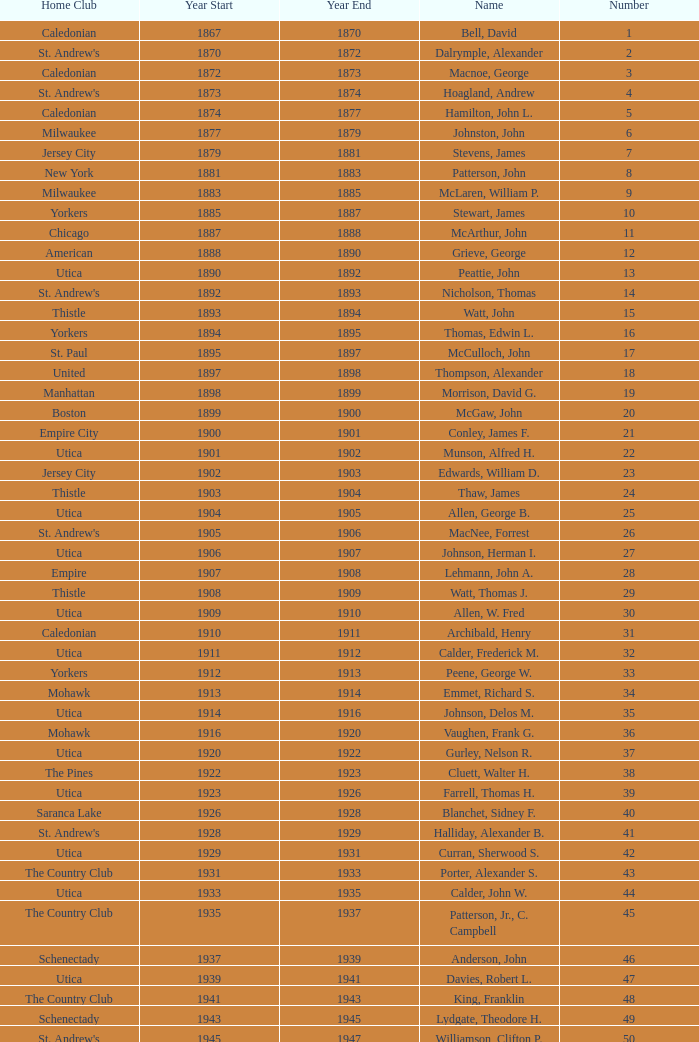Which Number has a Name of cooper, c. kenneth, and a Year End larger than 1984? None. Could you parse the entire table? {'header': ['Home Club', 'Year Start', 'Year End', 'Name', 'Number'], 'rows': [['Caledonian', '1867', '1870', 'Bell, David', '1'], ["St. Andrew's", '1870', '1872', 'Dalrymple, Alexander', '2'], ['Caledonian', '1872', '1873', 'Macnoe, George', '3'], ["St. Andrew's", '1873', '1874', 'Hoagland, Andrew', '4'], ['Caledonian', '1874', '1877', 'Hamilton, John L.', '5'], ['Milwaukee', '1877', '1879', 'Johnston, John', '6'], ['Jersey City', '1879', '1881', 'Stevens, James', '7'], ['New York', '1881', '1883', 'Patterson, John', '8'], ['Milwaukee', '1883', '1885', 'McLaren, William P.', '9'], ['Yorkers', '1885', '1887', 'Stewart, James', '10'], ['Chicago', '1887', '1888', 'McArthur, John', '11'], ['American', '1888', '1890', 'Grieve, George', '12'], ['Utica', '1890', '1892', 'Peattie, John', '13'], ["St. Andrew's", '1892', '1893', 'Nicholson, Thomas', '14'], ['Thistle', '1893', '1894', 'Watt, John', '15'], ['Yorkers', '1894', '1895', 'Thomas, Edwin L.', '16'], ['St. Paul', '1895', '1897', 'McCulloch, John', '17'], ['United', '1897', '1898', 'Thompson, Alexander', '18'], ['Manhattan', '1898', '1899', 'Morrison, David G.', '19'], ['Boston', '1899', '1900', 'McGaw, John', '20'], ['Empire City', '1900', '1901', 'Conley, James F.', '21'], ['Utica', '1901', '1902', 'Munson, Alfred H.', '22'], ['Jersey City', '1902', '1903', 'Edwards, William D.', '23'], ['Thistle', '1903', '1904', 'Thaw, James', '24'], ['Utica', '1904', '1905', 'Allen, George B.', '25'], ["St. Andrew's", '1905', '1906', 'MacNee, Forrest', '26'], ['Utica', '1906', '1907', 'Johnson, Herman I.', '27'], ['Empire', '1907', '1908', 'Lehmann, John A.', '28'], ['Thistle', '1908', '1909', 'Watt, Thomas J.', '29'], ['Utica', '1909', '1910', 'Allen, W. Fred', '30'], ['Caledonian', '1910', '1911', 'Archibald, Henry', '31'], ['Utica', '1911', '1912', 'Calder, Frederick M.', '32'], ['Yorkers', '1912', '1913', 'Peene, George W.', '33'], ['Mohawk', '1913', '1914', 'Emmet, Richard S.', '34'], ['Utica', '1914', '1916', 'Johnson, Delos M.', '35'], ['Mohawk', '1916', '1920', 'Vaughen, Frank G.', '36'], ['Utica', '1920', '1922', 'Gurley, Nelson R.', '37'], ['The Pines', '1922', '1923', 'Cluett, Walter H.', '38'], ['Utica', '1923', '1926', 'Farrell, Thomas H.', '39'], ['Saranca Lake', '1926', '1928', 'Blanchet, Sidney F.', '40'], ["St. Andrew's", '1928', '1929', 'Halliday, Alexander B.', '41'], ['Utica', '1929', '1931', 'Curran, Sherwood S.', '42'], ['The Country Club', '1931', '1933', 'Porter, Alexander S.', '43'], ['Utica', '1933', '1935', 'Calder, John W.', '44'], ['The Country Club', '1935', '1937', 'Patterson, Jr., C. Campbell', '45'], ['Schenectady', '1937', '1939', 'Anderson, John', '46'], ['Utica', '1939', '1941', 'Davies, Robert L.', '47'], ['The Country Club', '1941', '1943', 'King, Franklin', '48'], ['Schenectady', '1943', '1945', 'Lydgate, Theodore H.', '49'], ["St. Andrew's", '1945', '1947', 'Williamson, Clifton P.', '50'], ['Utica', '1947', '1949', 'Hurd, Kenneth S.', '51'], ['Ardsley', '1949', '1951', 'Hastings, Addison B.', '52'], ['The Country Club', '1951', '1953', 'Hill, Lucius T.', '53'], ['Schenectady', '1953', '1954', 'Davis, Richard P.', '54'], ['Winchester', '1954', '1956', 'Joy, John H.', '55'], ['Utica', '1956', '1957', 'Searle, William A.', '56'], ['Nashua', '1957', '1958', 'Smith, Dr. Deering G.', '57'], ["St. Andrew's", '1958', '1959', 'Seibert, W. Lincoln', '58'], ['Schenectady', '1959', '1961', 'Reid, Ralston B.', '59'], ['The Country Club', '1961', '1963', 'Cushing, Henry K.', '60'], ['Ardsley', '1963', '1965', 'Wood, Brenner R.', '61'], ['Utica', '1965', '1966', 'Parkinson, Fred E.', '62'], ['Norfolk', '1966', '1968', 'Childs, Edward C.', '63'], ['Albany', '1968', '1970', 'Rand, Grenfell N.', '64'], ['Winchester', '1970', '1972', 'Neill, Stanley E.', '65'], ['NY Caledonian', '1972', '1974', 'Milano, Dr. Joseph E.', '66'], ['Schenectady', '1974', '1976', 'Neuber, Dr. Richard A.', '67'], ['Utica', '1976', '1978', 'Cobb, Arthur J.', '68'], ['Petersham', '1978', '1980', 'Hamm, Arthur E.', '69'], ['Nutmeg', '1980', '1982', 'Will, A. Roland', '70'], ['NY Caledonian', '1982', '1984', 'Cooper, C. Kenneth', '71'], ['Wellesley', '1984', '1986', 'Porter, David R.', '72'], ['Schenectady', '1984', '1986', 'Millington, A. Wesley', '73'], ['Cape Cod', '1988', '1989', 'Dewees, Dr. David C.', '74'], ['Nutmeg', '1989', '1991', 'Owens, Charles D.', '75'], ['Garden State', '1991', '1993', 'Mitchell, J. Peter', '76'], ['Nashua', '1993', '1995', 'Lopez, Jr., Chester H.', '77'], ['Schenectady', '1995', '1997', 'Freeman, Kim', '78'], ['Broomstones', '1997', '1999', 'Williams, Samuel C.', '79'], ['Philadelphia', '1999', '2001', 'Hatch, Peggy', '80'], ['Utica', '2001', '2003', 'Garber, Thomas', '81'], ['Potomac', '2003', '2005', 'Pelletier, Robert', '82'], ['Broomstones', '2005', '2007', 'Chandler, Robert P.', '83'], ['Nashua', '2007', '2009', 'Krailo, Gwen', '84'], ['Utica', '2009', '2011', 'Thomas, Carl', '85'], ['Coastal Carolina', '2011', '2013', 'Macartney, Dick', '86']]} 